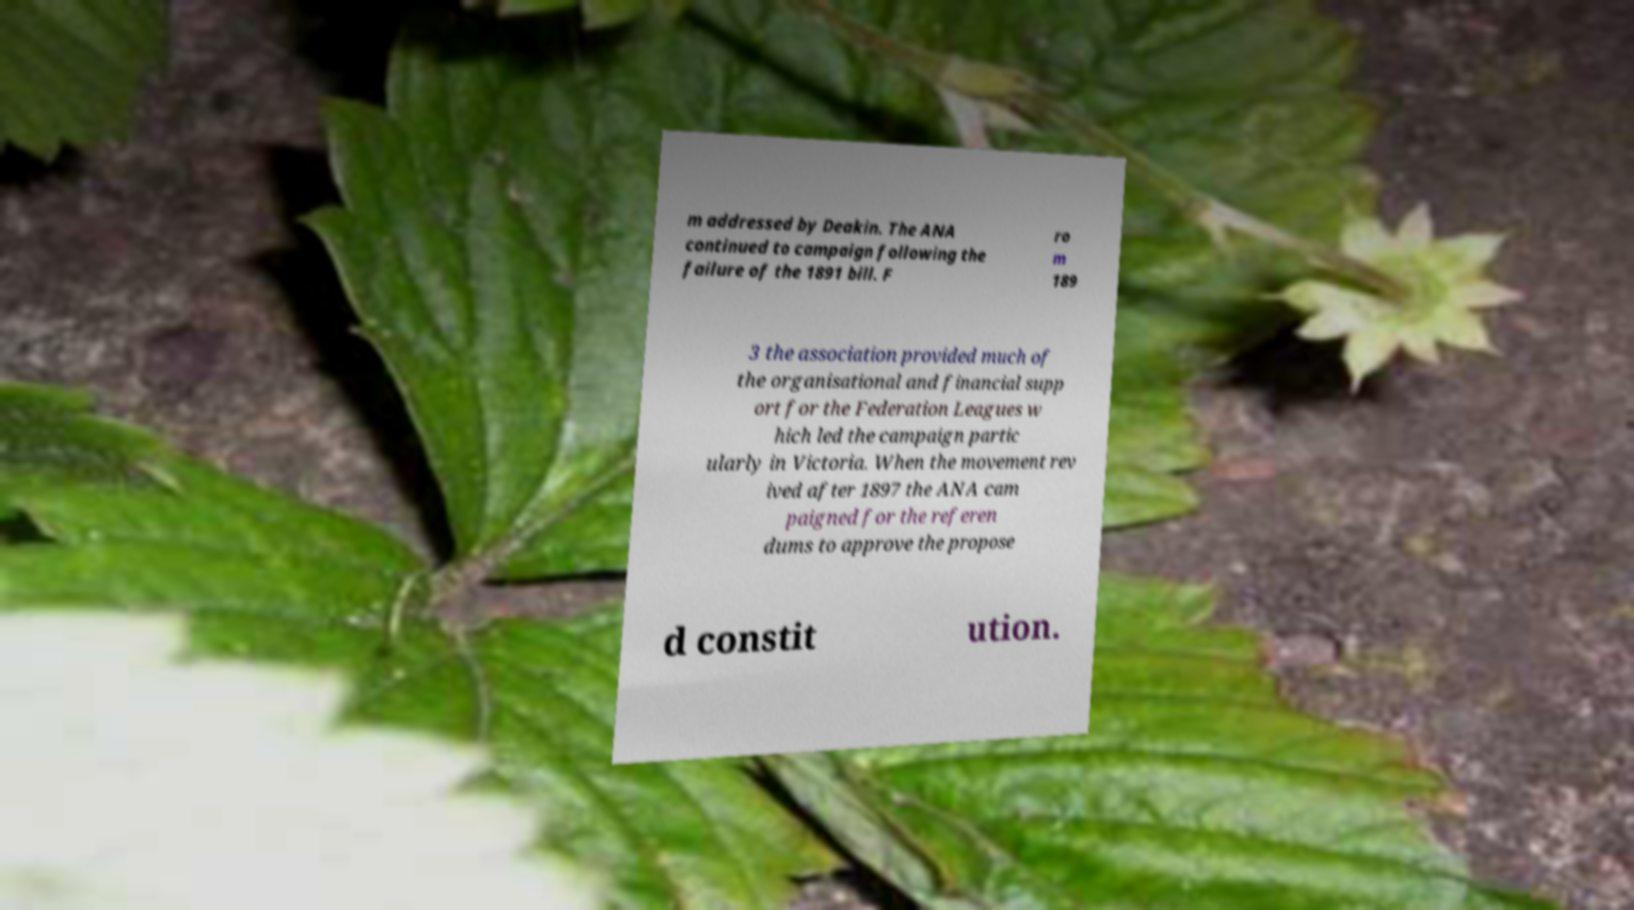Can you read and provide the text displayed in the image?This photo seems to have some interesting text. Can you extract and type it out for me? m addressed by Deakin. The ANA continued to campaign following the failure of the 1891 bill. F ro m 189 3 the association provided much of the organisational and financial supp ort for the Federation Leagues w hich led the campaign partic ularly in Victoria. When the movement rev ived after 1897 the ANA cam paigned for the referen dums to approve the propose d constit ution. 